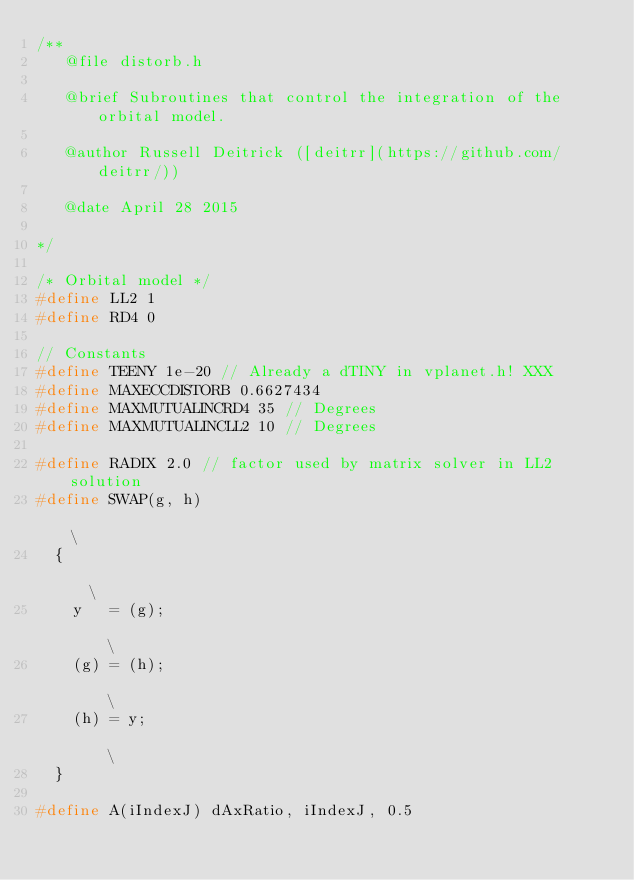<code> <loc_0><loc_0><loc_500><loc_500><_C_>/**
   @file distorb.h

   @brief Subroutines that control the integration of the orbital model.

   @author Russell Deitrick ([deitrr](https://github.com/deitrr/))

   @date April 28 2015

*/

/* Orbital model */
#define LL2 1
#define RD4 0

// Constants
#define TEENY 1e-20 // Already a dTINY in vplanet.h! XXX
#define MAXECCDISTORB 0.6627434
#define MAXMUTUALINCRD4 35 // Degrees
#define MAXMUTUALINCLL2 10 // Degrees

#define RADIX 2.0 // factor used by matrix solver in LL2 solution
#define SWAP(g, h)                                                             \
  {                                                                            \
    y   = (g);                                                                 \
    (g) = (h);                                                                 \
    (h) = y;                                                                   \
  }

#define A(iIndexJ) dAxRatio, iIndexJ, 0.5</code> 